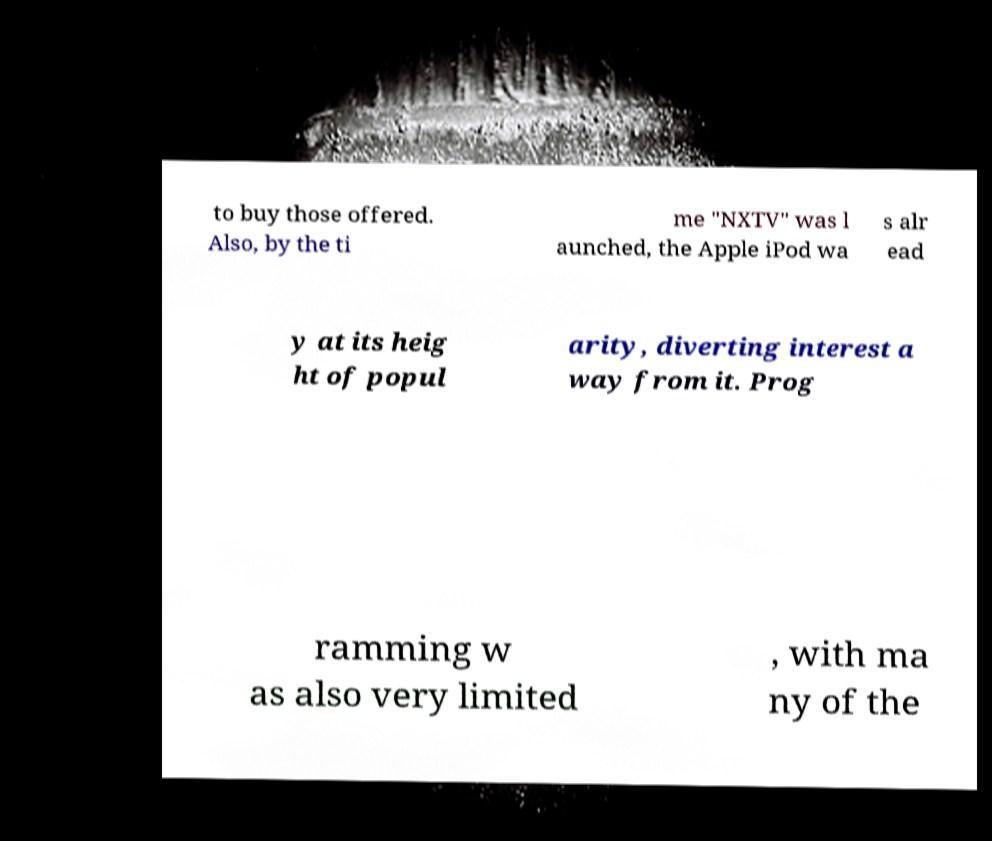What messages or text are displayed in this image? I need them in a readable, typed format. to buy those offered. Also, by the ti me "NXTV" was l aunched, the Apple iPod wa s alr ead y at its heig ht of popul arity, diverting interest a way from it. Prog ramming w as also very limited , with ma ny of the 